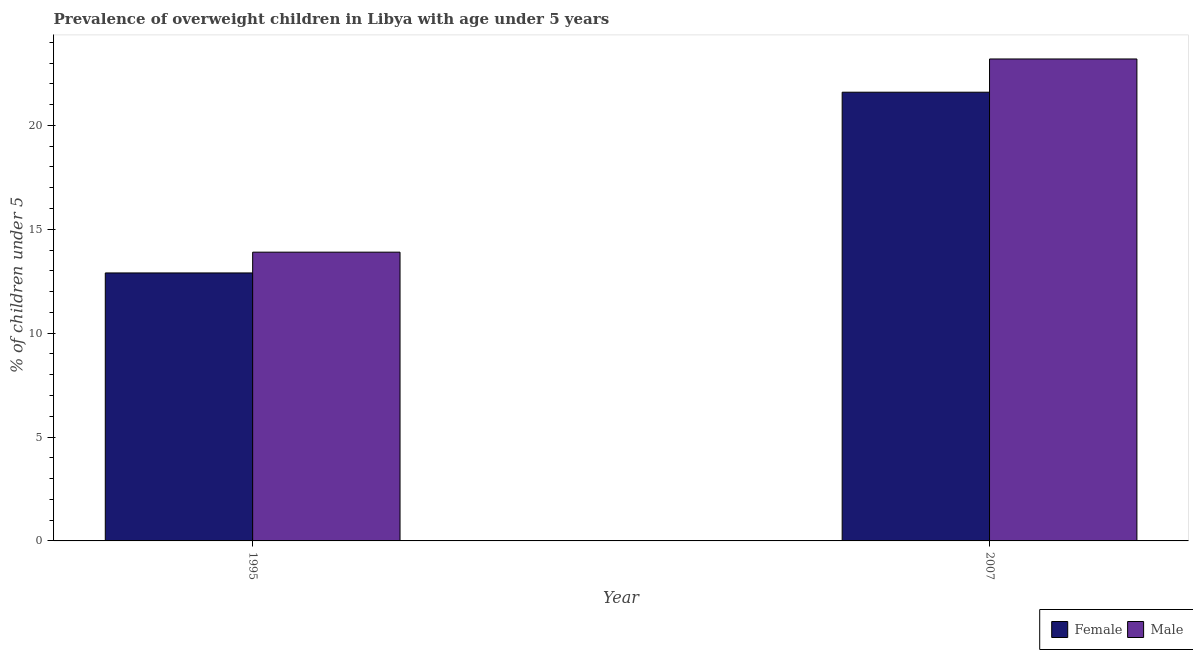How many different coloured bars are there?
Offer a very short reply. 2. How many groups of bars are there?
Your response must be concise. 2. Are the number of bars per tick equal to the number of legend labels?
Provide a succinct answer. Yes. How many bars are there on the 1st tick from the left?
Offer a terse response. 2. How many bars are there on the 2nd tick from the right?
Offer a very short reply. 2. What is the label of the 1st group of bars from the left?
Provide a succinct answer. 1995. In how many cases, is the number of bars for a given year not equal to the number of legend labels?
Provide a succinct answer. 0. What is the percentage of obese female children in 2007?
Keep it short and to the point. 21.6. Across all years, what is the maximum percentage of obese female children?
Ensure brevity in your answer.  21.6. Across all years, what is the minimum percentage of obese male children?
Offer a very short reply. 13.9. In which year was the percentage of obese female children minimum?
Offer a terse response. 1995. What is the total percentage of obese female children in the graph?
Give a very brief answer. 34.5. What is the difference between the percentage of obese female children in 1995 and that in 2007?
Offer a terse response. -8.7. What is the difference between the percentage of obese male children in 1995 and the percentage of obese female children in 2007?
Offer a very short reply. -9.3. What is the average percentage of obese female children per year?
Your response must be concise. 17.25. In the year 1995, what is the difference between the percentage of obese female children and percentage of obese male children?
Provide a succinct answer. 0. In how many years, is the percentage of obese male children greater than 4 %?
Your answer should be compact. 2. What is the ratio of the percentage of obese male children in 1995 to that in 2007?
Your response must be concise. 0.6. In how many years, is the percentage of obese female children greater than the average percentage of obese female children taken over all years?
Provide a succinct answer. 1. What does the 2nd bar from the left in 2007 represents?
Your answer should be very brief. Male. How many bars are there?
Give a very brief answer. 4. How many years are there in the graph?
Provide a succinct answer. 2. What is the difference between two consecutive major ticks on the Y-axis?
Your answer should be very brief. 5. Does the graph contain any zero values?
Provide a succinct answer. No. Does the graph contain grids?
Provide a succinct answer. No. How many legend labels are there?
Your answer should be very brief. 2. How are the legend labels stacked?
Your response must be concise. Horizontal. What is the title of the graph?
Your answer should be compact. Prevalence of overweight children in Libya with age under 5 years. What is the label or title of the X-axis?
Provide a short and direct response. Year. What is the label or title of the Y-axis?
Make the answer very short.  % of children under 5. What is the  % of children under 5 of Female in 1995?
Offer a very short reply. 12.9. What is the  % of children under 5 in Male in 1995?
Keep it short and to the point. 13.9. What is the  % of children under 5 of Female in 2007?
Offer a very short reply. 21.6. What is the  % of children under 5 of Male in 2007?
Your answer should be very brief. 23.2. Across all years, what is the maximum  % of children under 5 in Female?
Offer a terse response. 21.6. Across all years, what is the maximum  % of children under 5 of Male?
Your response must be concise. 23.2. Across all years, what is the minimum  % of children under 5 in Female?
Your answer should be compact. 12.9. Across all years, what is the minimum  % of children under 5 of Male?
Provide a short and direct response. 13.9. What is the total  % of children under 5 in Female in the graph?
Ensure brevity in your answer.  34.5. What is the total  % of children under 5 of Male in the graph?
Your answer should be very brief. 37.1. What is the difference between the  % of children under 5 in Male in 1995 and that in 2007?
Make the answer very short. -9.3. What is the difference between the  % of children under 5 of Female in 1995 and the  % of children under 5 of Male in 2007?
Your answer should be very brief. -10.3. What is the average  % of children under 5 of Female per year?
Give a very brief answer. 17.25. What is the average  % of children under 5 in Male per year?
Provide a succinct answer. 18.55. In the year 1995, what is the difference between the  % of children under 5 in Female and  % of children under 5 in Male?
Your answer should be compact. -1. In the year 2007, what is the difference between the  % of children under 5 in Female and  % of children under 5 in Male?
Offer a very short reply. -1.6. What is the ratio of the  % of children under 5 in Female in 1995 to that in 2007?
Your answer should be very brief. 0.6. What is the ratio of the  % of children under 5 of Male in 1995 to that in 2007?
Keep it short and to the point. 0.6. What is the difference between the highest and the lowest  % of children under 5 in Female?
Your response must be concise. 8.7. What is the difference between the highest and the lowest  % of children under 5 in Male?
Ensure brevity in your answer.  9.3. 